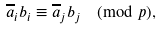Convert formula to latex. <formula><loc_0><loc_0><loc_500><loc_500>\overline { a } _ { i } b _ { i } \equiv \overline { a } _ { j } b _ { j } \pmod { p } ,</formula> 